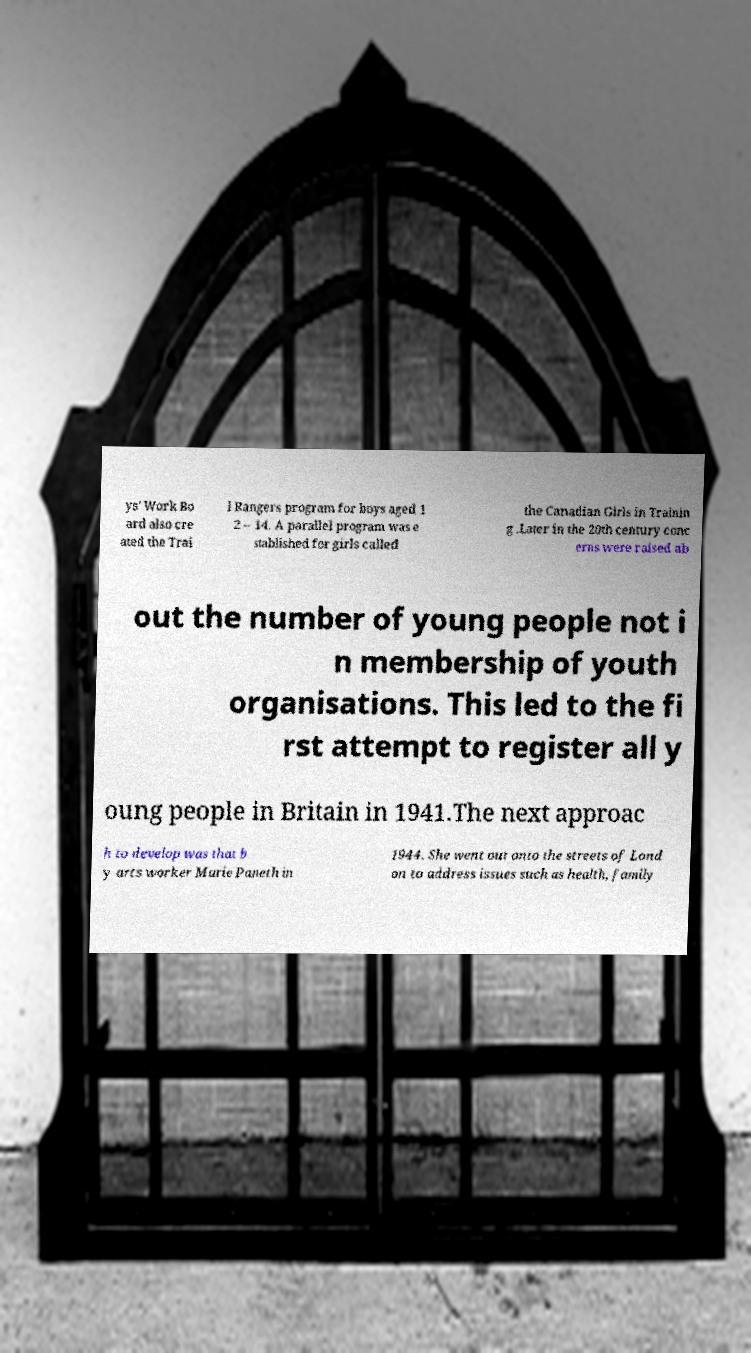There's text embedded in this image that I need extracted. Can you transcribe it verbatim? ys' Work Bo ard also cre ated the Trai l Rangers program for boys aged 1 2 – 14. A parallel program was e stablished for girls called the Canadian Girls in Trainin g .Later in the 20th century conc erns were raised ab out the number of young people not i n membership of youth organisations. This led to the fi rst attempt to register all y oung people in Britain in 1941.The next approac h to develop was that b y arts worker Marie Paneth in 1944. She went out onto the streets of Lond on to address issues such as health, family 